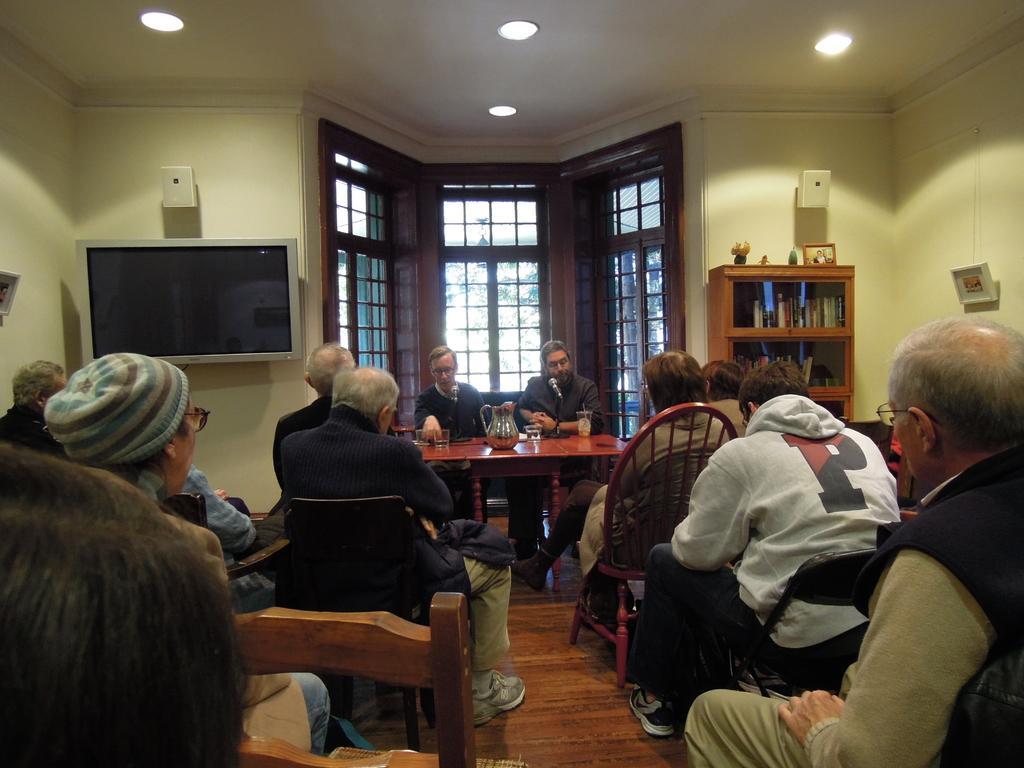Describe this image in one or two sentences. As we can see in the image there is a yellow color wall, window, television, shelves, few people sitting on chairs and a table. On table there are glasses and mug. 